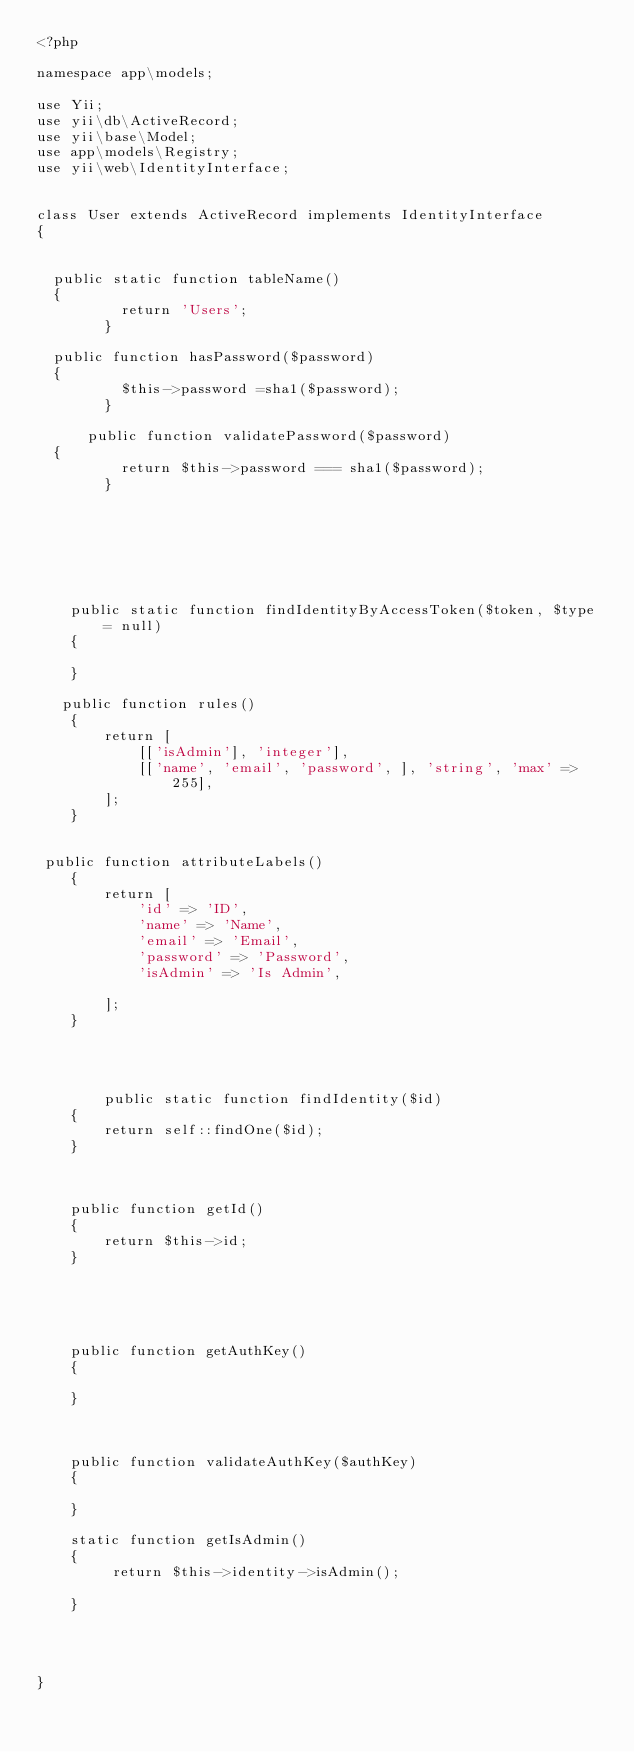<code> <loc_0><loc_0><loc_500><loc_500><_PHP_><?php

namespace app\models;

use Yii;
use yii\db\ActiveRecord;
use yii\base\Model;
use app\models\Registry;
use yii\web\IdentityInterface;


class User extends ActiveRecord implements IdentityInterface
{
    	
   
	public static function tableName()
	{
        	return 'Users';
        }
	
	public function hasPassword($password)
	{
        	$this->password =sha1($password);
        }
    	
    	public function validatePassword($password)
	{
        	return $this->password === sha1($password);
        }
	
	 
	
	


   
    public static function findIdentityByAccessToken($token, $type = null)
    {
        
    }

	 public function rules()
    {
        return [
            [['isAdmin'], 'integer'],
            [['name', 'email', 'password', ], 'string', 'max' => 255],
        ];
    }


 public function attributeLabels()
    {
        return [
            'id' => 'ID',
            'name' => 'Name',
            'email' => 'Email',
            'password' => 'Password',
            'isAdmin' => 'Is Admin',
           
        ];
    }




        public static function findIdentity($id)
    {
        return self::findOne($id);
    }
    
    
    
    public function getId()
    {
        return $this->id;
    }

    

    
    
    public function getAuthKey()
    {
        
    }

    
    
    public function validateAuthKey($authKey)
    {
       
    }
    
    static function getIsAdmin()
    {
         return $this->identity->isAdmin(); 
       
    }
    
    
    
    
}
  
  	
    

</code> 